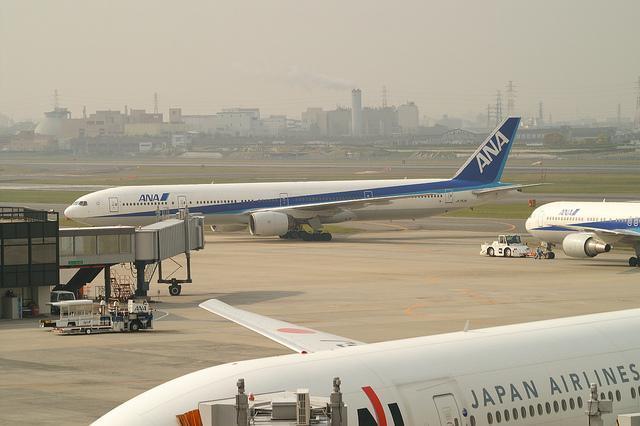How many airplanes can you see?
Give a very brief answer. 3. How many prongs does the fork have?
Give a very brief answer. 0. 